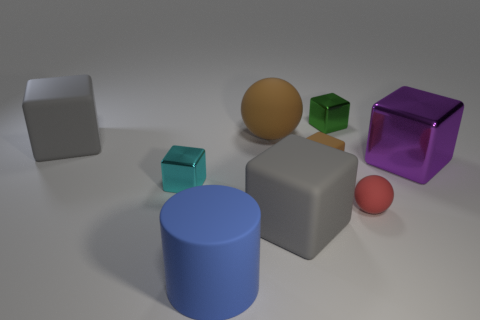What material is the purple object that is the same size as the matte cylinder?
Your answer should be compact. Metal. There is a metal object that is on the right side of the red sphere; are there any tiny metal blocks behind it?
Give a very brief answer. Yes. What number of other things are the same color as the large rubber sphere?
Make the answer very short. 1. The red rubber thing is what size?
Provide a short and direct response. Small. Are any tiny green rubber cylinders visible?
Offer a terse response. No. Are there more large cubes that are left of the brown ball than large spheres to the left of the rubber cylinder?
Provide a short and direct response. Yes. There is a thing that is right of the green cube and in front of the purple shiny cube; what is its material?
Give a very brief answer. Rubber. Is the green metal thing the same shape as the blue thing?
Your answer should be very brief. No. How many big gray matte cubes are in front of the big metallic block?
Provide a short and direct response. 1. There is a blue matte cylinder that is in front of the cyan block; is its size the same as the tiny green shiny block?
Your answer should be compact. No. 